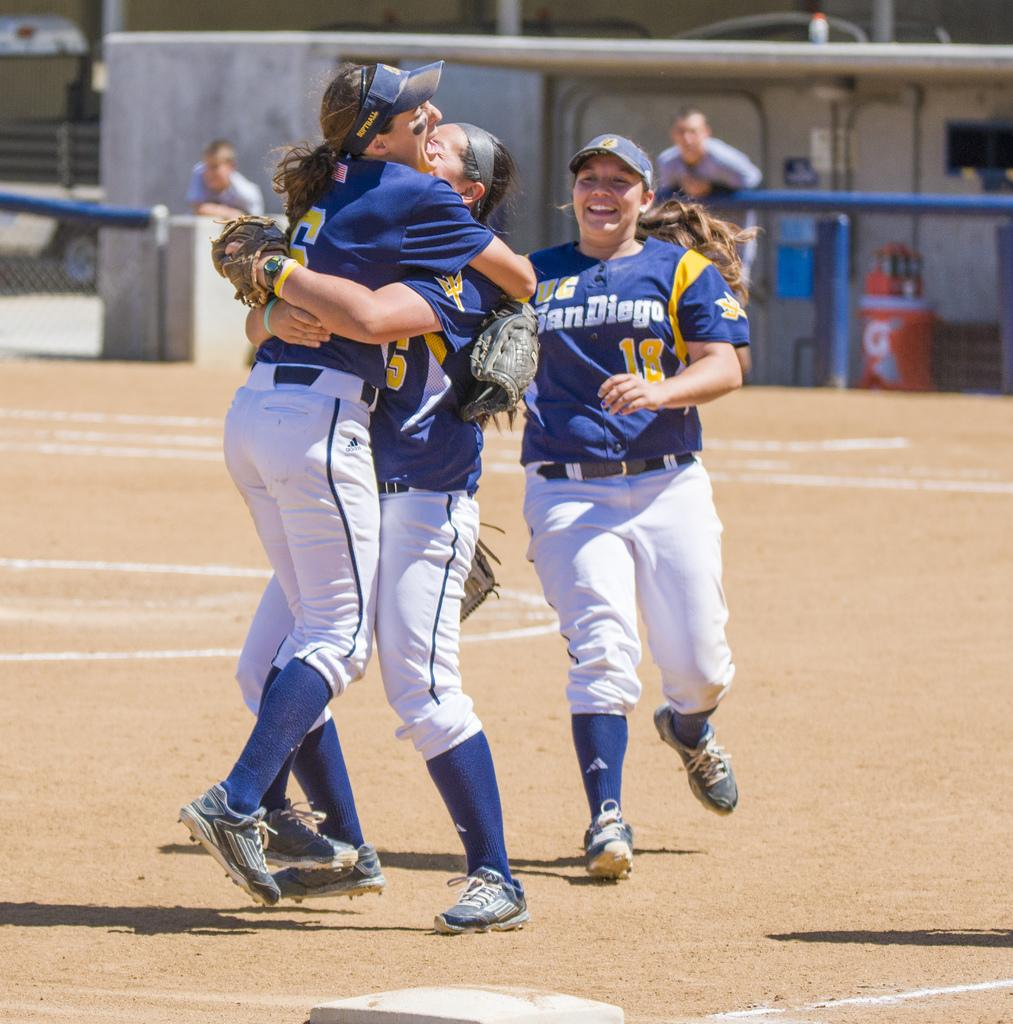<image>
Write a terse but informative summary of the picture. several happy players for uc san diego hugging 